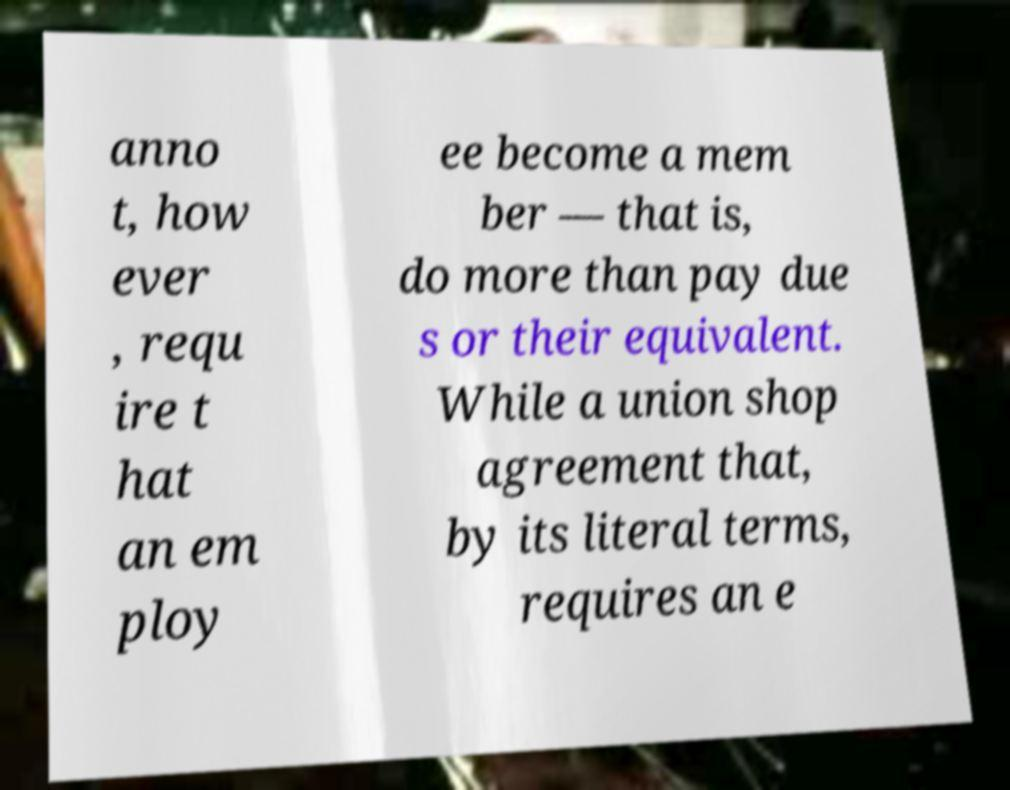Can you accurately transcribe the text from the provided image for me? anno t, how ever , requ ire t hat an em ploy ee become a mem ber — that is, do more than pay due s or their equivalent. While a union shop agreement that, by its literal terms, requires an e 